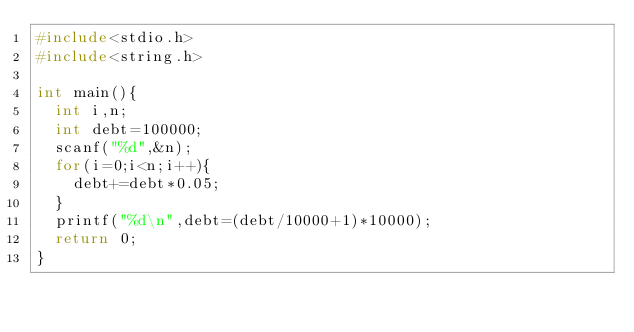Convert code to text. <code><loc_0><loc_0><loc_500><loc_500><_C_>#include<stdio.h>
#include<string.h>

int main(){
	int i,n;
	int debt=100000;
	scanf("%d",&n);
	for(i=0;i<n;i++){
		debt+=debt*0.05;
	}
	printf("%d\n",debt=(debt/10000+1)*10000);
	return 0;
}</code> 